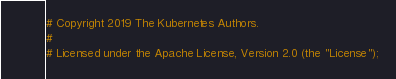<code> <loc_0><loc_0><loc_500><loc_500><_Bash_># Copyright 2019 The Kubernetes Authors.
#
# Licensed under the Apache License, Version 2.0 (the "License");</code> 